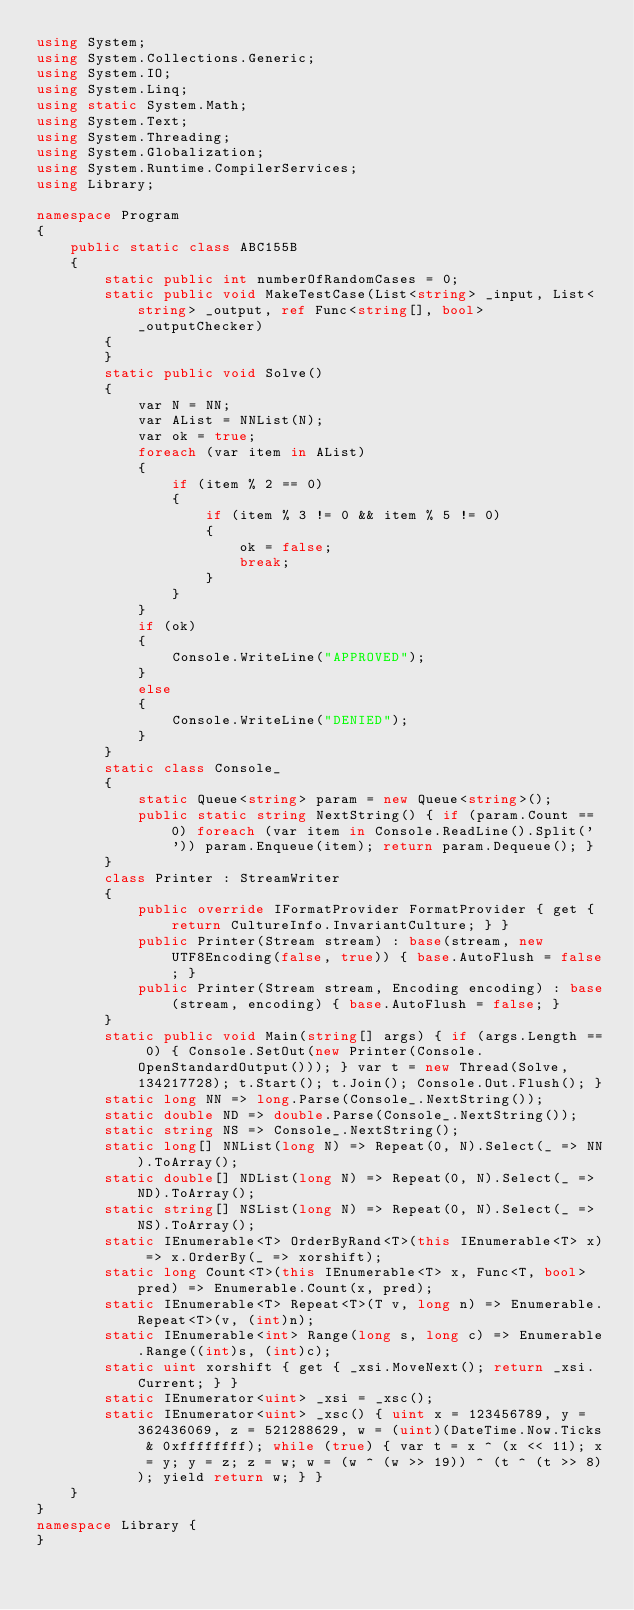Convert code to text. <code><loc_0><loc_0><loc_500><loc_500><_C#_>using System;
using System.Collections.Generic;
using System.IO;
using System.Linq;
using static System.Math;
using System.Text;
using System.Threading;
using System.Globalization;
using System.Runtime.CompilerServices;
using Library;

namespace Program
{
    public static class ABC155B
    {
        static public int numberOfRandomCases = 0;
        static public void MakeTestCase(List<string> _input, List<string> _output, ref Func<string[], bool> _outputChecker)
        {
        }
        static public void Solve()
        {
            var N = NN;
            var AList = NNList(N);
            var ok = true;
            foreach (var item in AList)
            {
                if (item % 2 == 0)
                {
                    if (item % 3 != 0 && item % 5 != 0)
                    {
                        ok = false;
                        break;
                    }
                }
            }
            if (ok)
            {
                Console.WriteLine("APPROVED");
            }
            else
            {
                Console.WriteLine("DENIED");
            }
        }
        static class Console_
        {
            static Queue<string> param = new Queue<string>();
            public static string NextString() { if (param.Count == 0) foreach (var item in Console.ReadLine().Split(' ')) param.Enqueue(item); return param.Dequeue(); }
        }
        class Printer : StreamWriter
        {
            public override IFormatProvider FormatProvider { get { return CultureInfo.InvariantCulture; } }
            public Printer(Stream stream) : base(stream, new UTF8Encoding(false, true)) { base.AutoFlush = false; }
            public Printer(Stream stream, Encoding encoding) : base(stream, encoding) { base.AutoFlush = false; }
        }
        static public void Main(string[] args) { if (args.Length == 0) { Console.SetOut(new Printer(Console.OpenStandardOutput())); } var t = new Thread(Solve, 134217728); t.Start(); t.Join(); Console.Out.Flush(); }
        static long NN => long.Parse(Console_.NextString());
        static double ND => double.Parse(Console_.NextString());
        static string NS => Console_.NextString();
        static long[] NNList(long N) => Repeat(0, N).Select(_ => NN).ToArray();
        static double[] NDList(long N) => Repeat(0, N).Select(_ => ND).ToArray();
        static string[] NSList(long N) => Repeat(0, N).Select(_ => NS).ToArray();
        static IEnumerable<T> OrderByRand<T>(this IEnumerable<T> x) => x.OrderBy(_ => xorshift);
        static long Count<T>(this IEnumerable<T> x, Func<T, bool> pred) => Enumerable.Count(x, pred);
        static IEnumerable<T> Repeat<T>(T v, long n) => Enumerable.Repeat<T>(v, (int)n);
        static IEnumerable<int> Range(long s, long c) => Enumerable.Range((int)s, (int)c);
        static uint xorshift { get { _xsi.MoveNext(); return _xsi.Current; } }
        static IEnumerator<uint> _xsi = _xsc();
        static IEnumerator<uint> _xsc() { uint x = 123456789, y = 362436069, z = 521288629, w = (uint)(DateTime.Now.Ticks & 0xffffffff); while (true) { var t = x ^ (x << 11); x = y; y = z; z = w; w = (w ^ (w >> 19)) ^ (t ^ (t >> 8)); yield return w; } }
    }
}
namespace Library {
}
</code> 